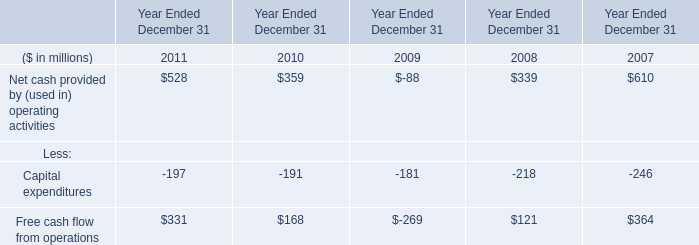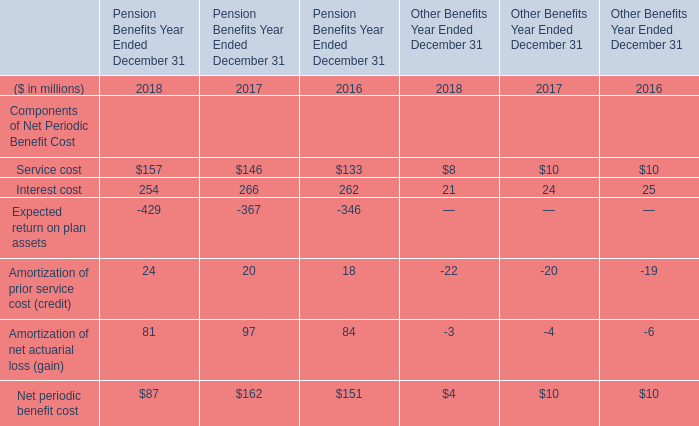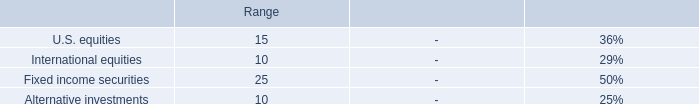What do all elements for Pension Benefits Year Ended December 31 sum up, excluding those negative ones in 2018 ? (in million) 
Computations: (((157 + 254) + 24) + 81)
Answer: 516.0. 